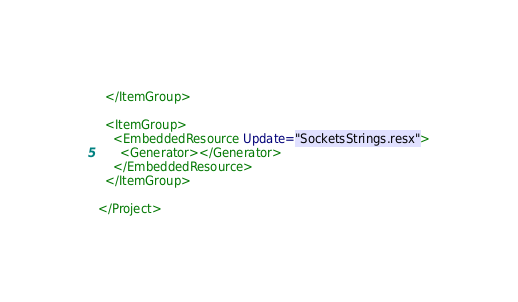<code> <loc_0><loc_0><loc_500><loc_500><_XML_>  </ItemGroup>

  <ItemGroup>
    <EmbeddedResource Update="SocketsStrings.resx">
      <Generator></Generator>
    </EmbeddedResource>
  </ItemGroup>

</Project>
</code> 